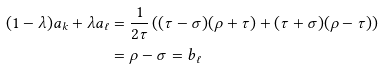Convert formula to latex. <formula><loc_0><loc_0><loc_500><loc_500>( 1 - \lambda ) a _ { k } + \lambda a _ { \ell } & = \frac { 1 } { 2 \tau } \left ( ( \tau - \sigma ) ( \rho + \tau ) + ( \tau + \sigma ) ( \rho - \tau ) \right ) \\ & = \rho - \sigma = b _ { \ell }</formula> 